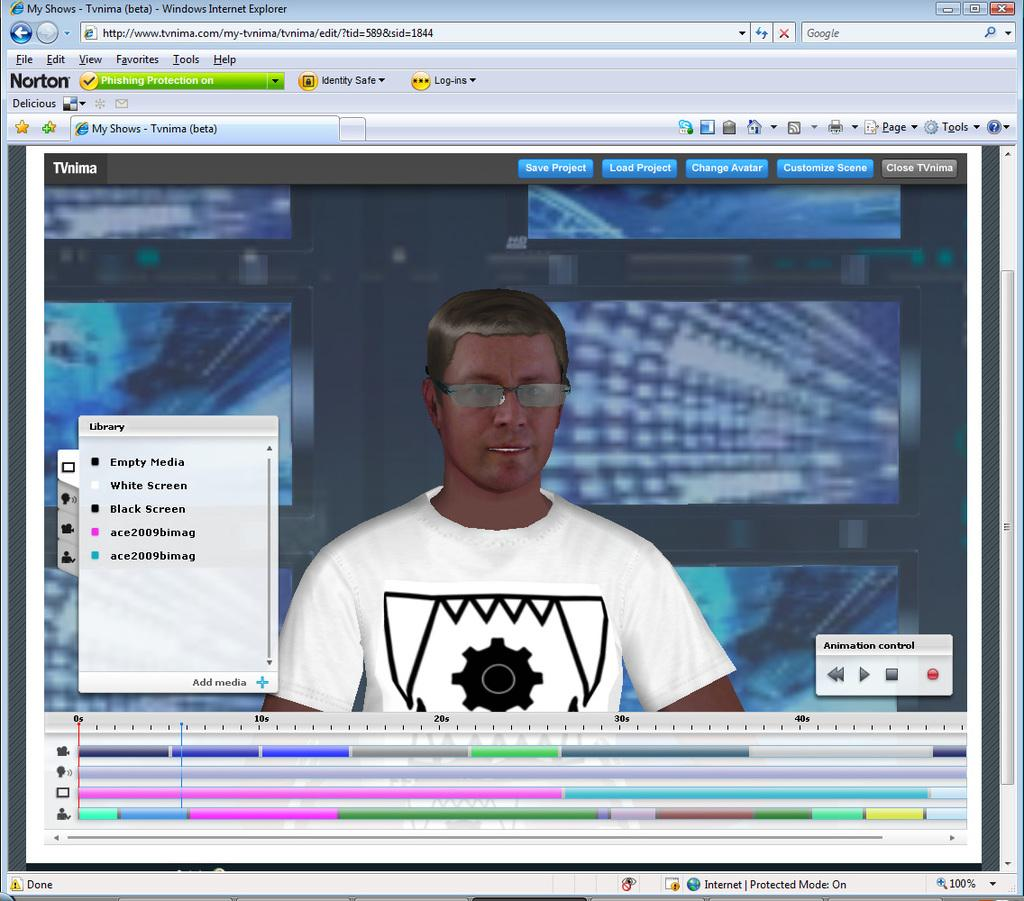What type of content is displayed in the image? The image contains a web page. Can you describe the person depicted on the web page? There is a depiction of a person on the web page. What feature is present at the top of the image? There is a search bar at the top of the image. How many apples are hanging from the bell in the image? There is no bell or apples present in the image. 